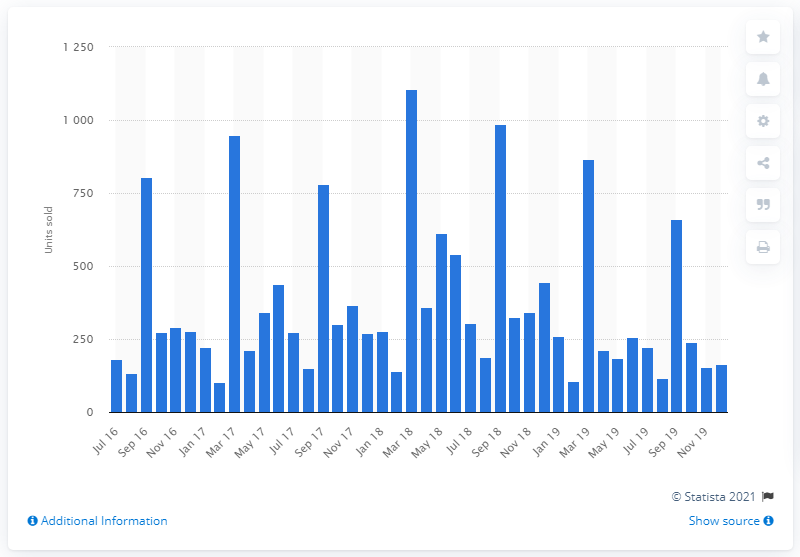Identify some key points in this picture. In July 2019, a total of 221 new Abarth cars were sold. 